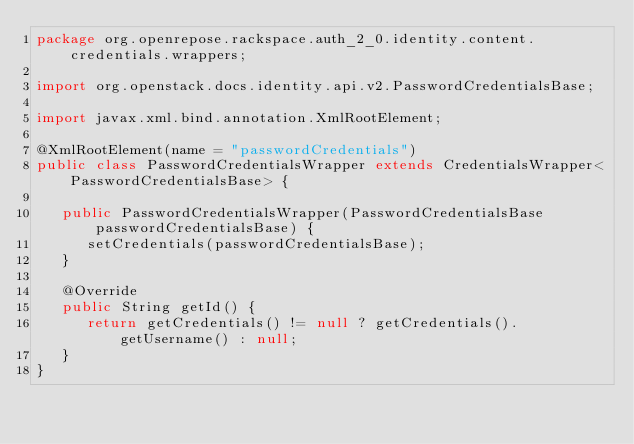Convert code to text. <code><loc_0><loc_0><loc_500><loc_500><_Java_>package org.openrepose.rackspace.auth_2_0.identity.content.credentials.wrappers;

import org.openstack.docs.identity.api.v2.PasswordCredentialsBase;

import javax.xml.bind.annotation.XmlRootElement;

@XmlRootElement(name = "passwordCredentials")
public class PasswordCredentialsWrapper extends CredentialsWrapper<PasswordCredentialsBase> {

   public PasswordCredentialsWrapper(PasswordCredentialsBase passwordCredentialsBase) {
      setCredentials(passwordCredentialsBase);
   }

   @Override
   public String getId() {
      return getCredentials() != null ? getCredentials().getUsername() : null;
   }
}
</code> 